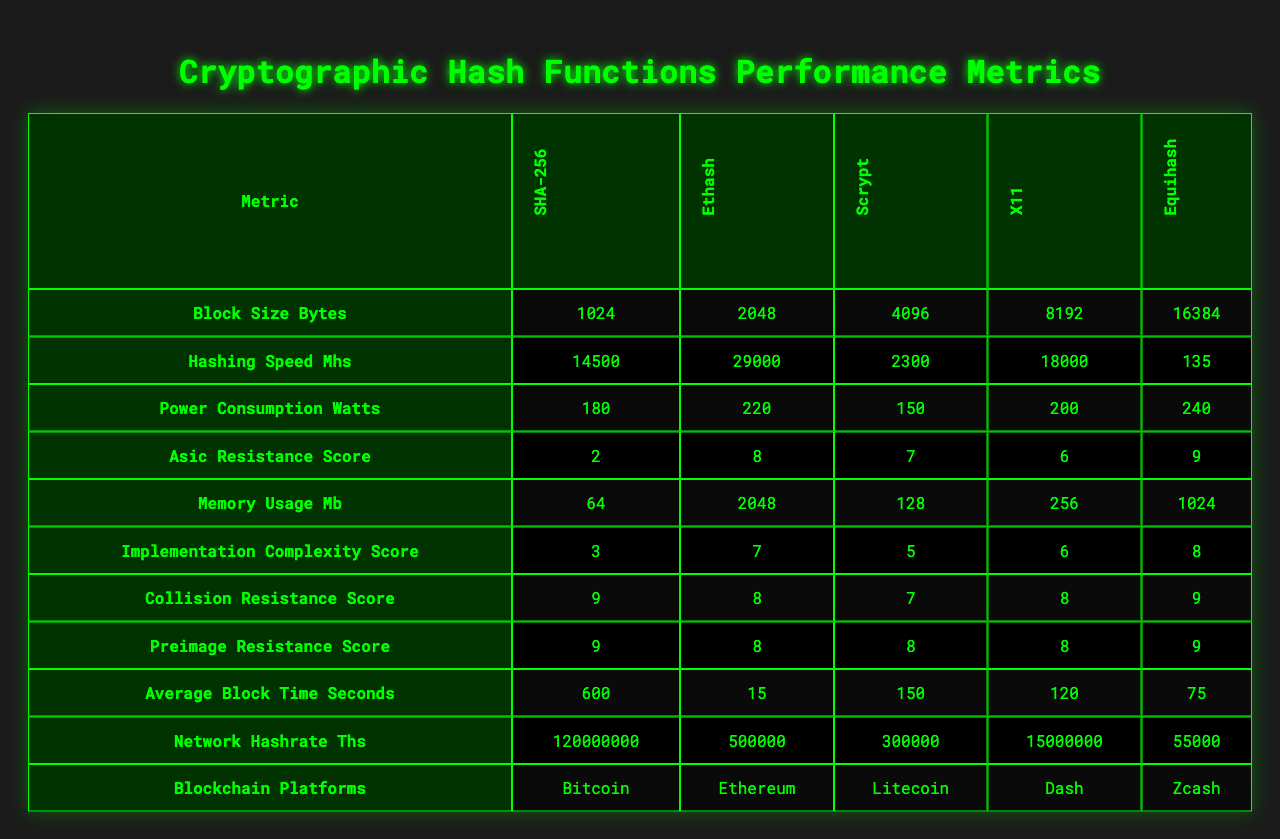What is the hashing speed of SHA-256? The table shows that the hashing speed for SHA-256 is 14500 megahashes per second (MH/s).
Answer: 14500 MH/s Which hash function has the highest power consumption? Reviewing the power consumption values, Equihash has the highest consumption at 240 watts.
Answer: 240 watts What is the memory usage of Scrypt? The table indicates that Scrypt requires 128 megabytes (MB) of memory.
Answer: 128 MB Is the collision resistance score for Ethash equal to 8? The table confirms that Ethash has a collision resistance score of 8, which is indeed correct.
Answer: Yes Which hash function has the lowest average block time? Upon comparing the average block times, Ethash has the lowest value at 15 seconds.
Answer: 15 seconds What is the difference in hashing speed between X11 and Scrypt? The hashing speed for X11 is 18000 MH/s and for Scrypt it is 2300 MH/s. The difference is 18000 - 2300 = 15700 MH/s.
Answer: 15700 MH/s What is the average block size across all hash functions? The block sizes are 1024, 2048, 4096, 8192, and 16384 bytes. Summing these gives 1024 + 2048 + 4096 + 8192 + 16384 = 32704 bytes, then divide by 5 (number of hash functions) to find the average, which is 32704 / 5 = 6540.8 bytes.
Answer: 6540.8 bytes Which hash function has both the highest ASIC resistance score and the highest power consumption? Comparing the values, Equihash has the highest ASIC resistance score of 9 but the highest power consumption is 240 watts from Equihash as well. No other function meets both criteria.
Answer: Yes, Equihash What hash function is utilized by the Zcash platform? The table indicates that Zcash uses the Equihash hash function for its mining process.
Answer: Equihash Is there a hash function that has a power consumption under 200 watts? By examining the power consumption data, both SHA-256 (180 watts) and Scrypt (150 watts) fall under 200 watts.
Answer: Yes 